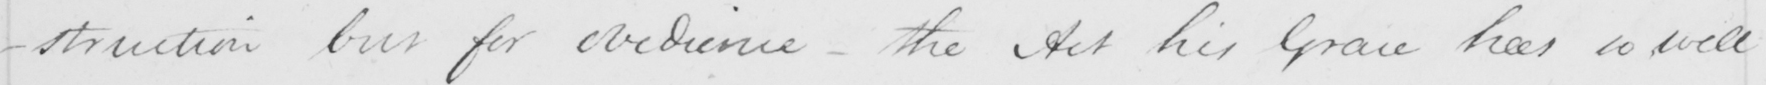Transcribe the text shown in this historical manuscript line. -struction but for obedience - the Act his Grace has so well 